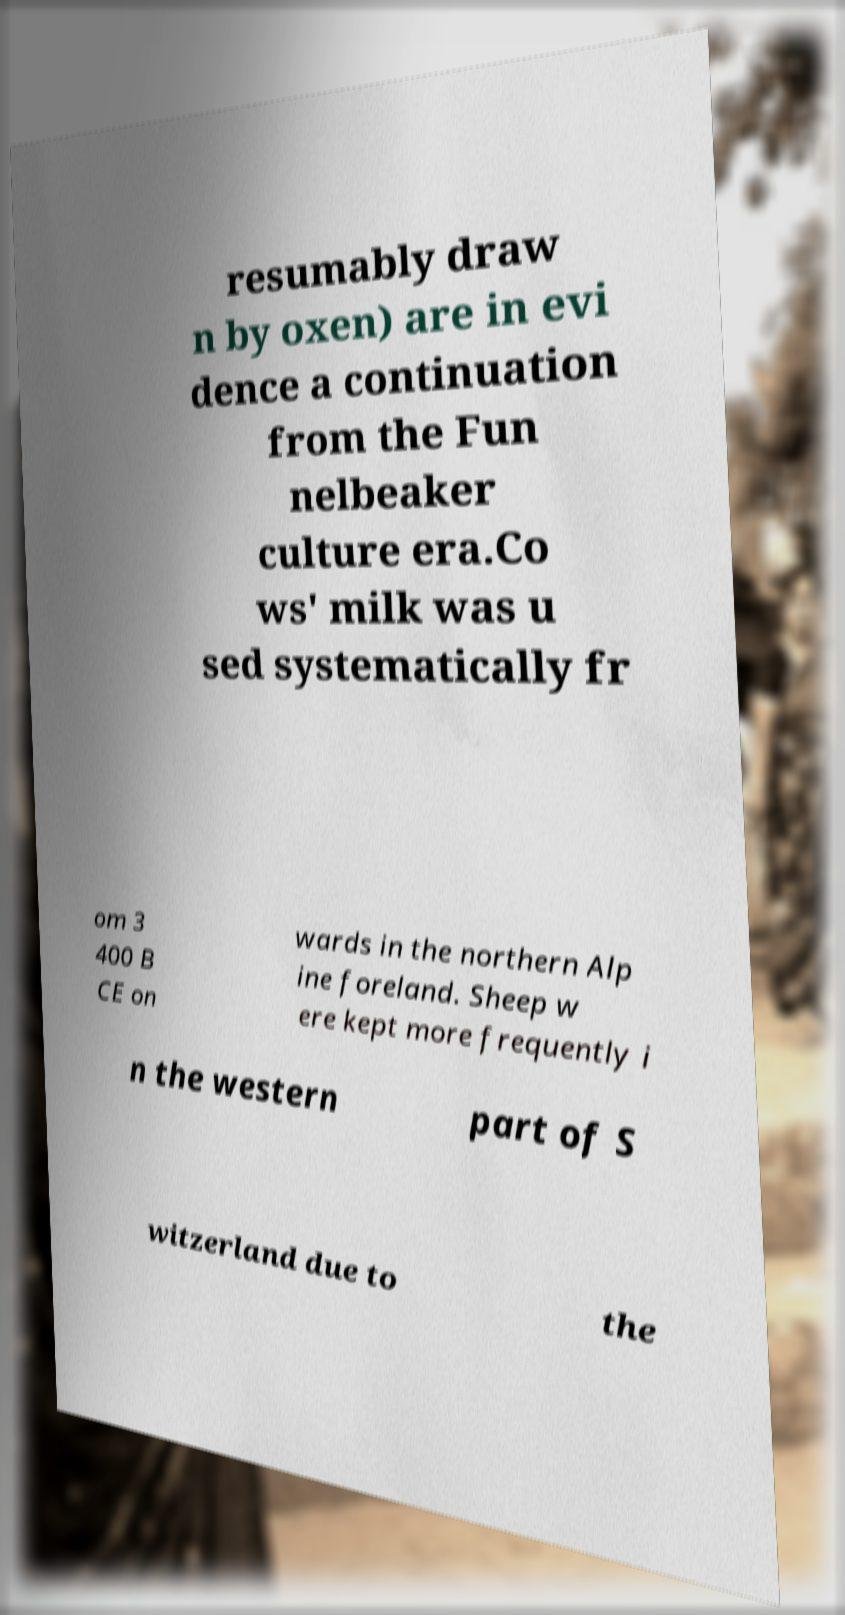Can you accurately transcribe the text from the provided image for me? resumably draw n by oxen) are in evi dence a continuation from the Fun nelbeaker culture era.Co ws' milk was u sed systematically fr om 3 400 B CE on wards in the northern Alp ine foreland. Sheep w ere kept more frequently i n the western part of S witzerland due to the 